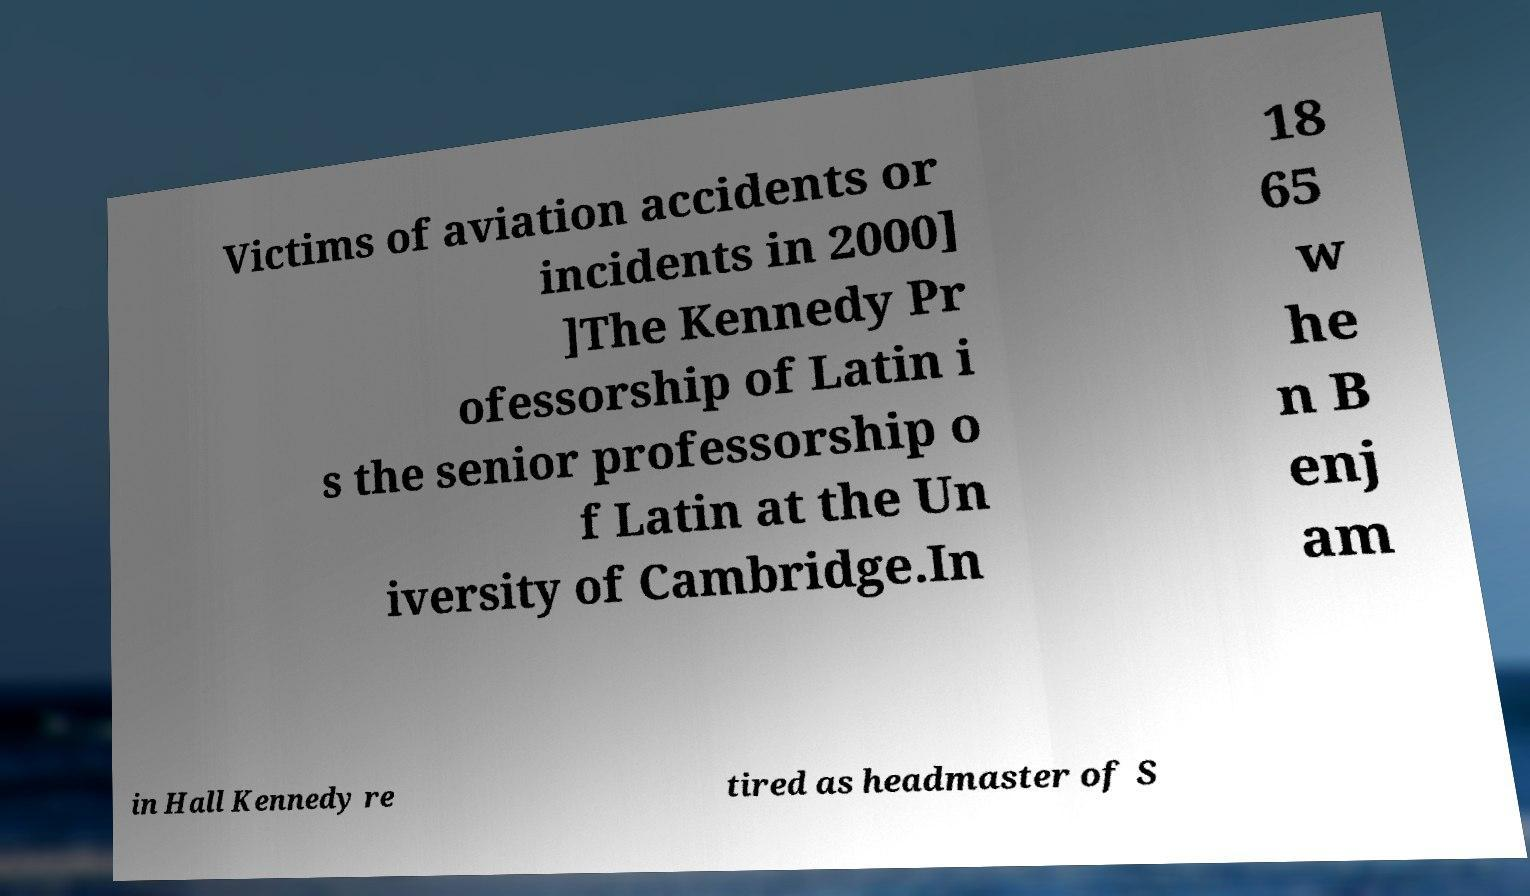I need the written content from this picture converted into text. Can you do that? Victims of aviation accidents or incidents in 2000] ]The Kennedy Pr ofessorship of Latin i s the senior professorship o f Latin at the Un iversity of Cambridge.In 18 65 w he n B enj am in Hall Kennedy re tired as headmaster of S 